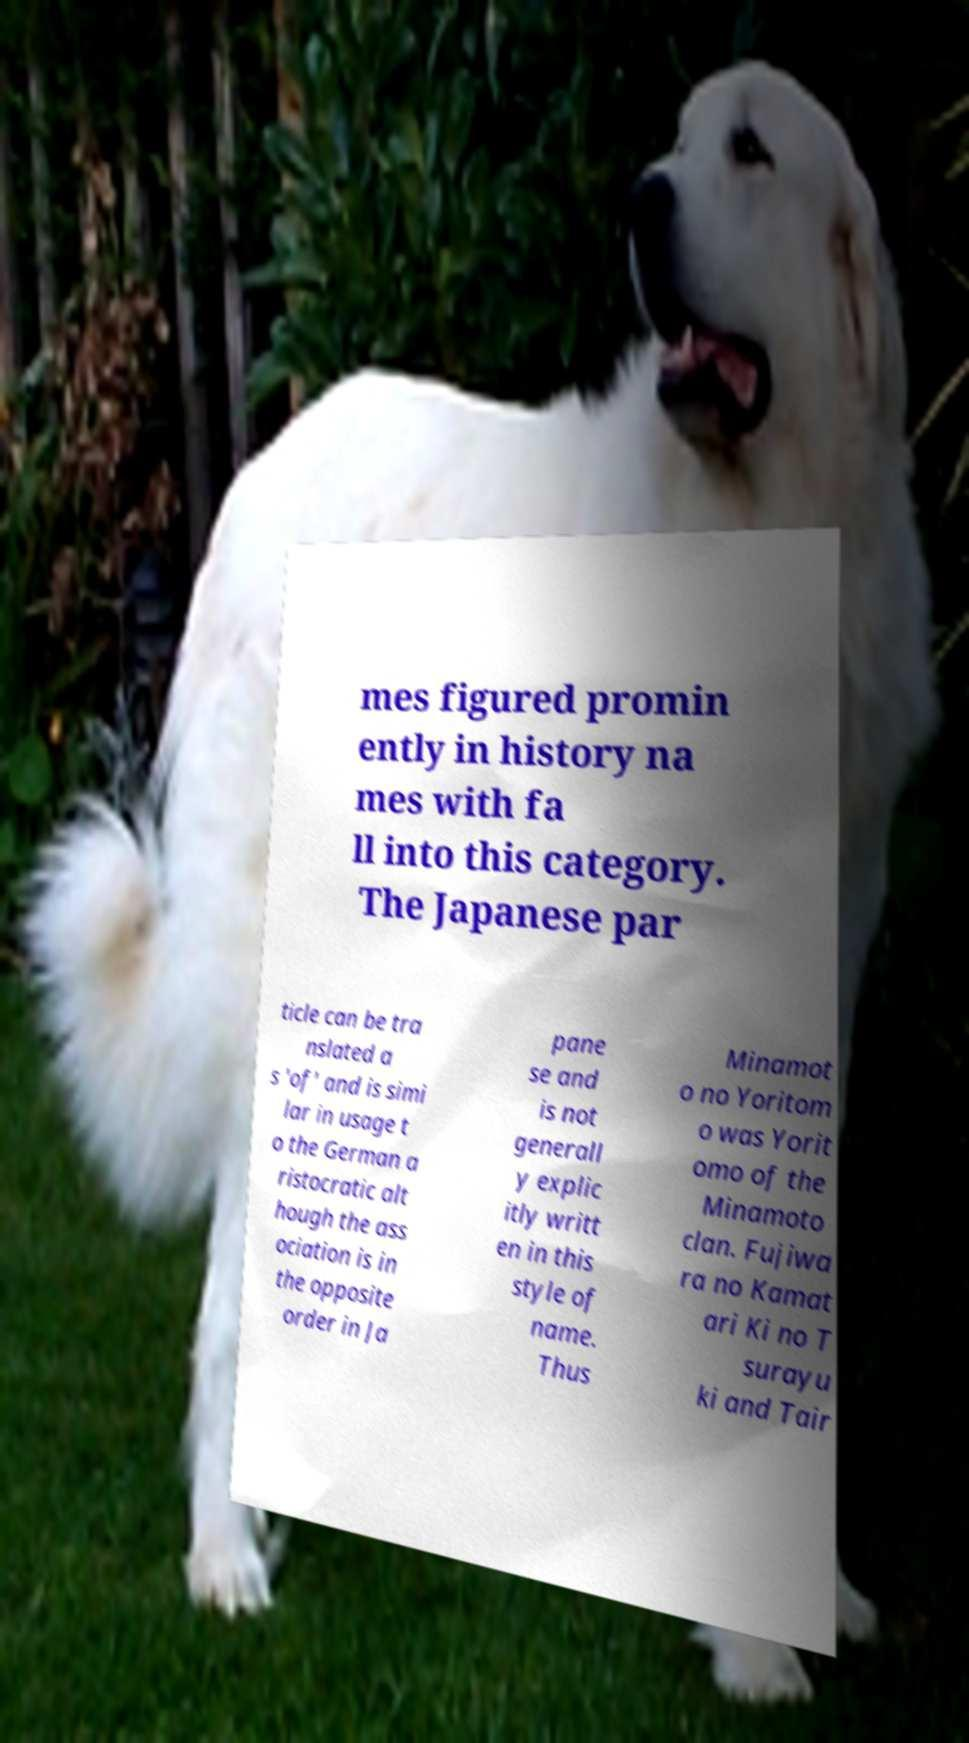There's text embedded in this image that I need extracted. Can you transcribe it verbatim? mes figured promin ently in history na mes with fa ll into this category. The Japanese par ticle can be tra nslated a s 'of' and is simi lar in usage t o the German a ristocratic alt hough the ass ociation is in the opposite order in Ja pane se and is not generall y explic itly writt en in this style of name. Thus Minamot o no Yoritom o was Yorit omo of the Minamoto clan. Fujiwa ra no Kamat ari Ki no T surayu ki and Tair 